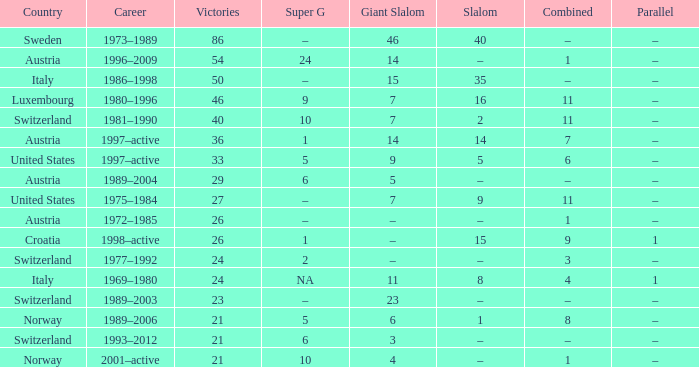What Country has a Career of 1989–2004? Austria. 